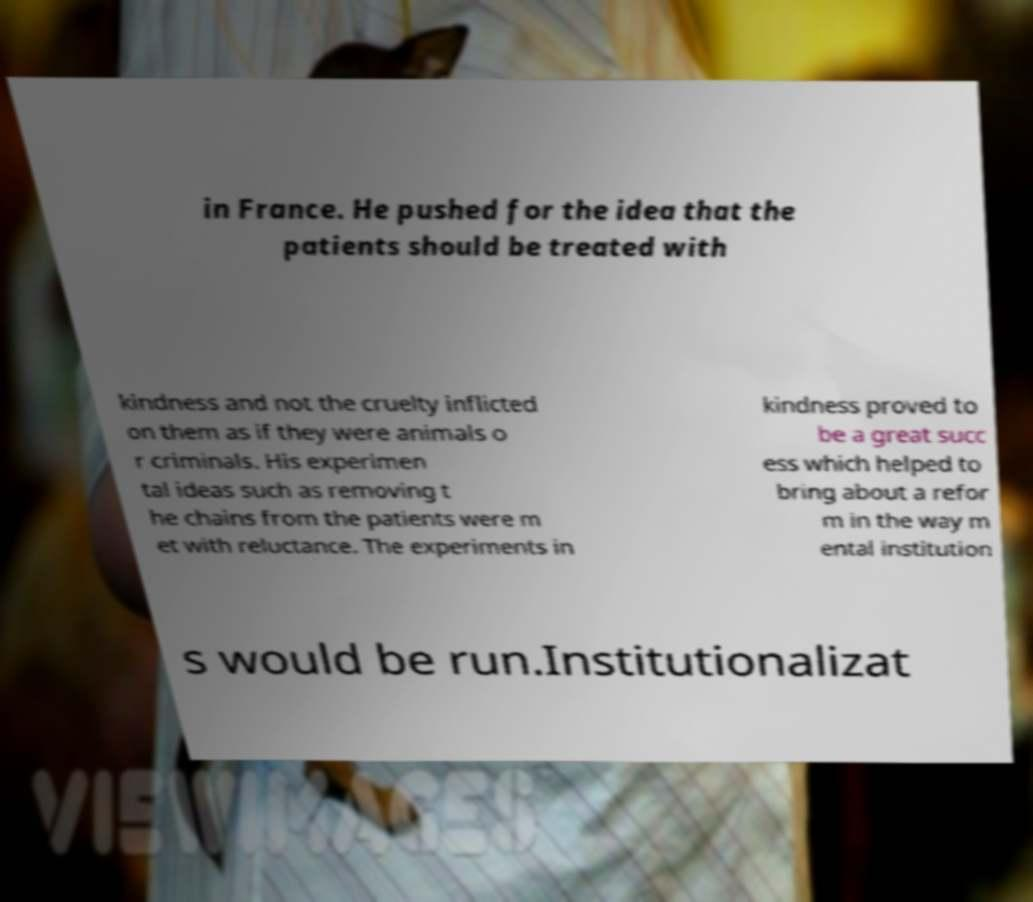What messages or text are displayed in this image? I need them in a readable, typed format. in France. He pushed for the idea that the patients should be treated with kindness and not the cruelty inflicted on them as if they were animals o r criminals. His experimen tal ideas such as removing t he chains from the patients were m et with reluctance. The experiments in kindness proved to be a great succ ess which helped to bring about a refor m in the way m ental institution s would be run.Institutionalizat 